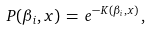<formula> <loc_0><loc_0><loc_500><loc_500>P ( \beta _ { i } , x ) \, = \, e ^ { - K ( \beta _ { i } , x ) } \, ,</formula> 